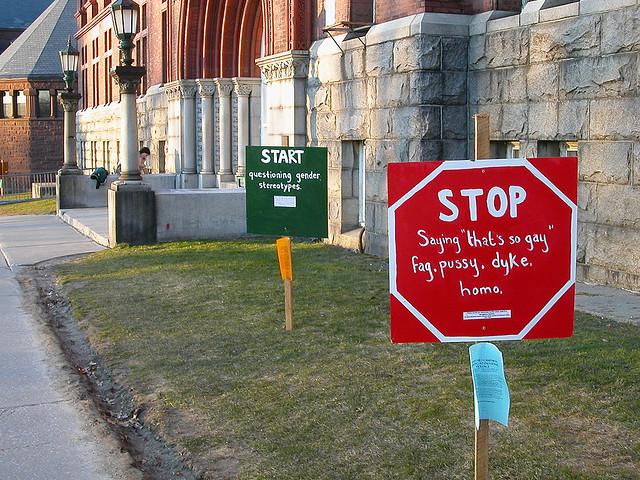Is it raining?
Keep it brief. No. Could these signs be in-appropriate?
Be succinct. Yes. What do the signs say?
Concise answer only. Stop. What is the first word on the green sign?
Be succinct. Start. 